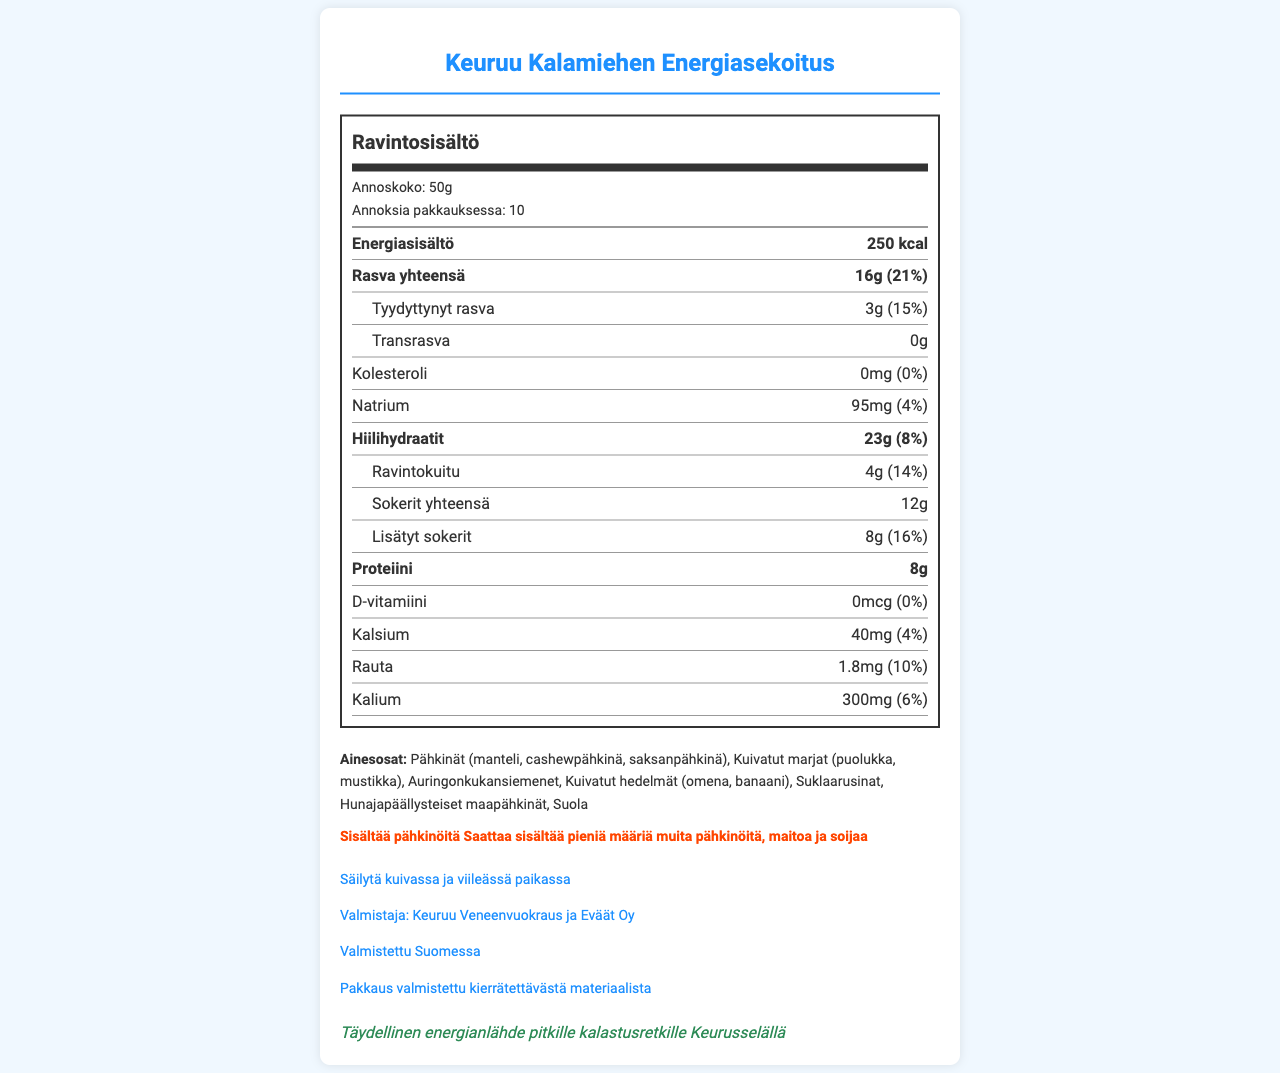what is the product name? The product name is stated at the top of the document.
Answer: Keuruu Kalamiehen Energiasekoitus what is the serving size of the trail mix? The serving size is stated at the top section of the nutrition label as "Annoskoko: 50g".
Answer: 50g how many servings are in the container? The servings per container are mentioned as "Annoksia pakkauksessa: 10".
Answer: 10 what is the total calorie content per serving? The total calorie content per serving is listed in the first row under "Energiasisältö".
Answer: 250 kcal what ingredients are in the trail mix? The ingredients are listed in the "Ainesosat" section of the document.
Answer: Pähkinät (manteli, cashewpähkinä, saksanpähkinä), Kuivatut marjat (puolukka, mustikka), Auringonkukansiemenet, Kuivatut hedelmät (omena, banaani), Suklaarusinat, Hunajapäällysteiset maapähkinät, Suola what is the sodium content per serving? The sodium content per serving is indicated as "Natrium: 95mg".
Answer: 95mg how much protein does one serving contain? The protein content per serving is listed as "Proteiini: 8g".
Answer: 8g which of the following is not an ingredient in the trail mix? I. Manteli II. Mustikka III. Banaani IV. Appelsiini The ingredients listed do not include "Appelsiini (orange)".
Answer: IV. Appelsiini how many grams of dietary fiber does each serving provide? A. 3g B. 4g C. 5g D. 6g The document states "Ravintokuitu: 4g".
Answer: B. 4g what percentage of the daily value is the total fat content per serving? The daily value percentage for total fat is listed as "Rasva yhteensä: 16g (21%)".
Answer: 21% is there any trans fat in the trail mix? The document specifies "Transrasva: 0g", indicating no trans fat.
Answer: No how should the trail mix be stored? The storage instructions are provided in the extra-info section as "Säilytä kuivassa ja viileässä paikassa".
Answer: Säilytä kuivassa ja viileässä paikassa who is the manufacturer of this trail mix? The document lists the manufacturer as "Keuruu Veneenvuokraus ja Eväät Oy".
Answer: Keuruu Veneenvuokraus ja Eväät Oy are there any allergens present in the trail mix? The document states "Sisältää pähkinöitä" and "Saattaa sisältää pieniä määriä muita pähkinöitä, maitoa ja soijaa", indicating the presence of allergens.
Answer: Yes summarize the main idea of the document. This summary covers the core details present in the document, synthesizing the main points about the nutritional content, ingredients, and additional information about the product.
Answer: The document provides nutritional information and ingredients for "Keuruu Kalamiehen Energiasekoitus", a high-energy trail mix ideal for fishing trips. It includes details about serving size, calories, fats, carbohydrates, protein, vitamins, and minerals. It also lists the ingredients and allergens and offers storage instructions. The product is manufactured by "Keuruu Veneenvuokraus ja Eväät Oy" and is made in Finland. what is the exact address of the manufacturer? The document specifies the manufacturer but does not provide an address. Therefore, the exact address cannot be determined based on the visual information.
Answer: Not enough information 